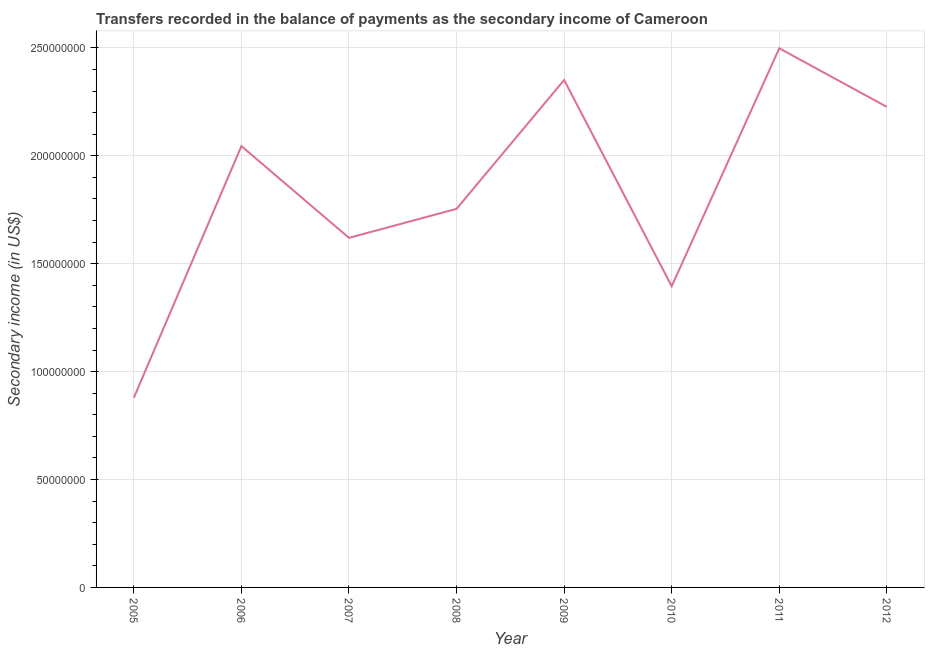What is the amount of secondary income in 2009?
Provide a short and direct response. 2.35e+08. Across all years, what is the maximum amount of secondary income?
Provide a short and direct response. 2.50e+08. Across all years, what is the minimum amount of secondary income?
Ensure brevity in your answer.  8.79e+07. In which year was the amount of secondary income maximum?
Your answer should be very brief. 2011. What is the sum of the amount of secondary income?
Your response must be concise. 1.48e+09. What is the difference between the amount of secondary income in 2006 and 2010?
Your answer should be very brief. 6.49e+07. What is the average amount of secondary income per year?
Your answer should be compact. 1.85e+08. What is the median amount of secondary income?
Your answer should be compact. 1.90e+08. Do a majority of the years between 2009 and 2007 (inclusive) have amount of secondary income greater than 70000000 US$?
Ensure brevity in your answer.  No. What is the ratio of the amount of secondary income in 2009 to that in 2011?
Keep it short and to the point. 0.94. Is the amount of secondary income in 2006 less than that in 2011?
Offer a terse response. Yes. Is the difference between the amount of secondary income in 2006 and 2012 greater than the difference between any two years?
Give a very brief answer. No. What is the difference between the highest and the second highest amount of secondary income?
Make the answer very short. 1.47e+07. Is the sum of the amount of secondary income in 2011 and 2012 greater than the maximum amount of secondary income across all years?
Ensure brevity in your answer.  Yes. What is the difference between the highest and the lowest amount of secondary income?
Your response must be concise. 1.62e+08. In how many years, is the amount of secondary income greater than the average amount of secondary income taken over all years?
Your answer should be very brief. 4. Does the amount of secondary income monotonically increase over the years?
Your answer should be compact. No. What is the difference between two consecutive major ticks on the Y-axis?
Provide a short and direct response. 5.00e+07. Are the values on the major ticks of Y-axis written in scientific E-notation?
Ensure brevity in your answer.  No. Does the graph contain any zero values?
Your answer should be compact. No. What is the title of the graph?
Provide a short and direct response. Transfers recorded in the balance of payments as the secondary income of Cameroon. What is the label or title of the Y-axis?
Ensure brevity in your answer.  Secondary income (in US$). What is the Secondary income (in US$) in 2005?
Give a very brief answer. 8.79e+07. What is the Secondary income (in US$) of 2006?
Offer a terse response. 2.04e+08. What is the Secondary income (in US$) in 2007?
Offer a very short reply. 1.62e+08. What is the Secondary income (in US$) in 2008?
Your answer should be very brief. 1.75e+08. What is the Secondary income (in US$) in 2009?
Your answer should be very brief. 2.35e+08. What is the Secondary income (in US$) of 2010?
Make the answer very short. 1.40e+08. What is the Secondary income (in US$) in 2011?
Provide a succinct answer. 2.50e+08. What is the Secondary income (in US$) in 2012?
Your response must be concise. 2.23e+08. What is the difference between the Secondary income (in US$) in 2005 and 2006?
Your response must be concise. -1.17e+08. What is the difference between the Secondary income (in US$) in 2005 and 2007?
Your response must be concise. -7.41e+07. What is the difference between the Secondary income (in US$) in 2005 and 2008?
Provide a succinct answer. -8.75e+07. What is the difference between the Secondary income (in US$) in 2005 and 2009?
Keep it short and to the point. -1.47e+08. What is the difference between the Secondary income (in US$) in 2005 and 2010?
Ensure brevity in your answer.  -5.17e+07. What is the difference between the Secondary income (in US$) in 2005 and 2011?
Give a very brief answer. -1.62e+08. What is the difference between the Secondary income (in US$) in 2005 and 2012?
Give a very brief answer. -1.35e+08. What is the difference between the Secondary income (in US$) in 2006 and 2007?
Provide a succinct answer. 4.25e+07. What is the difference between the Secondary income (in US$) in 2006 and 2008?
Offer a terse response. 2.91e+07. What is the difference between the Secondary income (in US$) in 2006 and 2009?
Keep it short and to the point. -3.06e+07. What is the difference between the Secondary income (in US$) in 2006 and 2010?
Offer a terse response. 6.49e+07. What is the difference between the Secondary income (in US$) in 2006 and 2011?
Offer a very short reply. -4.53e+07. What is the difference between the Secondary income (in US$) in 2006 and 2012?
Make the answer very short. -1.82e+07. What is the difference between the Secondary income (in US$) in 2007 and 2008?
Keep it short and to the point. -1.34e+07. What is the difference between the Secondary income (in US$) in 2007 and 2009?
Keep it short and to the point. -7.31e+07. What is the difference between the Secondary income (in US$) in 2007 and 2010?
Give a very brief answer. 2.24e+07. What is the difference between the Secondary income (in US$) in 2007 and 2011?
Offer a very short reply. -8.78e+07. What is the difference between the Secondary income (in US$) in 2007 and 2012?
Ensure brevity in your answer.  -6.07e+07. What is the difference between the Secondary income (in US$) in 2008 and 2009?
Your answer should be very brief. -5.97e+07. What is the difference between the Secondary income (in US$) in 2008 and 2010?
Provide a short and direct response. 3.59e+07. What is the difference between the Secondary income (in US$) in 2008 and 2011?
Make the answer very short. -7.44e+07. What is the difference between the Secondary income (in US$) in 2008 and 2012?
Offer a very short reply. -4.72e+07. What is the difference between the Secondary income (in US$) in 2009 and 2010?
Offer a terse response. 9.56e+07. What is the difference between the Secondary income (in US$) in 2009 and 2011?
Provide a succinct answer. -1.47e+07. What is the difference between the Secondary income (in US$) in 2009 and 2012?
Ensure brevity in your answer.  1.25e+07. What is the difference between the Secondary income (in US$) in 2010 and 2011?
Your answer should be very brief. -1.10e+08. What is the difference between the Secondary income (in US$) in 2010 and 2012?
Give a very brief answer. -8.31e+07. What is the difference between the Secondary income (in US$) in 2011 and 2012?
Your response must be concise. 2.71e+07. What is the ratio of the Secondary income (in US$) in 2005 to that in 2006?
Your answer should be compact. 0.43. What is the ratio of the Secondary income (in US$) in 2005 to that in 2007?
Offer a very short reply. 0.54. What is the ratio of the Secondary income (in US$) in 2005 to that in 2008?
Make the answer very short. 0.5. What is the ratio of the Secondary income (in US$) in 2005 to that in 2009?
Your response must be concise. 0.37. What is the ratio of the Secondary income (in US$) in 2005 to that in 2010?
Offer a terse response. 0.63. What is the ratio of the Secondary income (in US$) in 2005 to that in 2011?
Offer a very short reply. 0.35. What is the ratio of the Secondary income (in US$) in 2005 to that in 2012?
Keep it short and to the point. 0.4. What is the ratio of the Secondary income (in US$) in 2006 to that in 2007?
Provide a succinct answer. 1.26. What is the ratio of the Secondary income (in US$) in 2006 to that in 2008?
Provide a succinct answer. 1.17. What is the ratio of the Secondary income (in US$) in 2006 to that in 2009?
Your response must be concise. 0.87. What is the ratio of the Secondary income (in US$) in 2006 to that in 2010?
Provide a succinct answer. 1.47. What is the ratio of the Secondary income (in US$) in 2006 to that in 2011?
Ensure brevity in your answer.  0.82. What is the ratio of the Secondary income (in US$) in 2006 to that in 2012?
Offer a terse response. 0.92. What is the ratio of the Secondary income (in US$) in 2007 to that in 2008?
Your answer should be compact. 0.92. What is the ratio of the Secondary income (in US$) in 2007 to that in 2009?
Give a very brief answer. 0.69. What is the ratio of the Secondary income (in US$) in 2007 to that in 2010?
Offer a very short reply. 1.16. What is the ratio of the Secondary income (in US$) in 2007 to that in 2011?
Provide a succinct answer. 0.65. What is the ratio of the Secondary income (in US$) in 2007 to that in 2012?
Make the answer very short. 0.73. What is the ratio of the Secondary income (in US$) in 2008 to that in 2009?
Ensure brevity in your answer.  0.75. What is the ratio of the Secondary income (in US$) in 2008 to that in 2010?
Offer a very short reply. 1.26. What is the ratio of the Secondary income (in US$) in 2008 to that in 2011?
Your response must be concise. 0.7. What is the ratio of the Secondary income (in US$) in 2008 to that in 2012?
Ensure brevity in your answer.  0.79. What is the ratio of the Secondary income (in US$) in 2009 to that in 2010?
Your answer should be compact. 1.69. What is the ratio of the Secondary income (in US$) in 2009 to that in 2011?
Make the answer very short. 0.94. What is the ratio of the Secondary income (in US$) in 2009 to that in 2012?
Your answer should be very brief. 1.06. What is the ratio of the Secondary income (in US$) in 2010 to that in 2011?
Keep it short and to the point. 0.56. What is the ratio of the Secondary income (in US$) in 2010 to that in 2012?
Provide a short and direct response. 0.63. What is the ratio of the Secondary income (in US$) in 2011 to that in 2012?
Offer a very short reply. 1.12. 